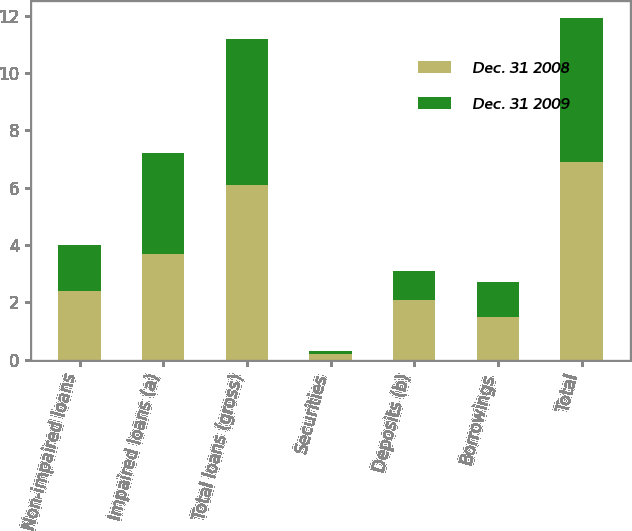Convert chart to OTSL. <chart><loc_0><loc_0><loc_500><loc_500><stacked_bar_chart><ecel><fcel>Non-impaired loans<fcel>Impaired loans (a)<fcel>Total loans (gross)<fcel>Securities<fcel>Deposits (b)<fcel>Borrowings<fcel>Total<nl><fcel>Dec. 31 2008<fcel>2.4<fcel>3.7<fcel>6.1<fcel>0.2<fcel>2.1<fcel>1.5<fcel>6.9<nl><fcel>Dec. 31 2009<fcel>1.6<fcel>3.5<fcel>5.1<fcel>0.1<fcel>1<fcel>1.2<fcel>5<nl></chart> 